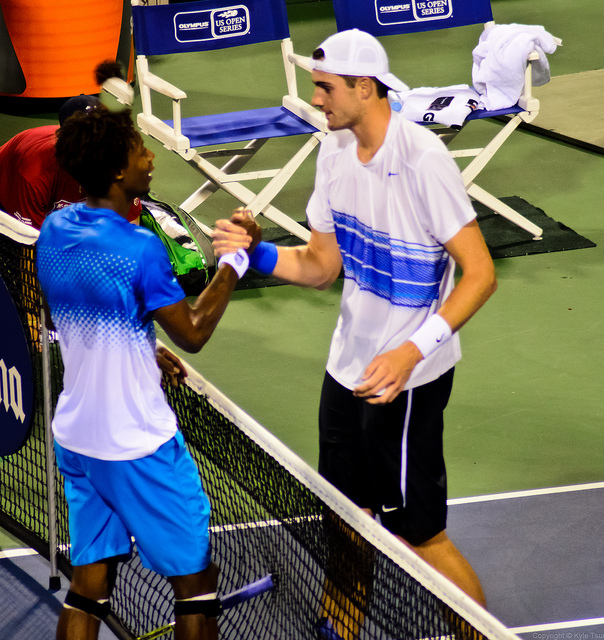Read and extract the text from this image. Q U5 OPEN US OPEN SERIES SERTES OPEN 